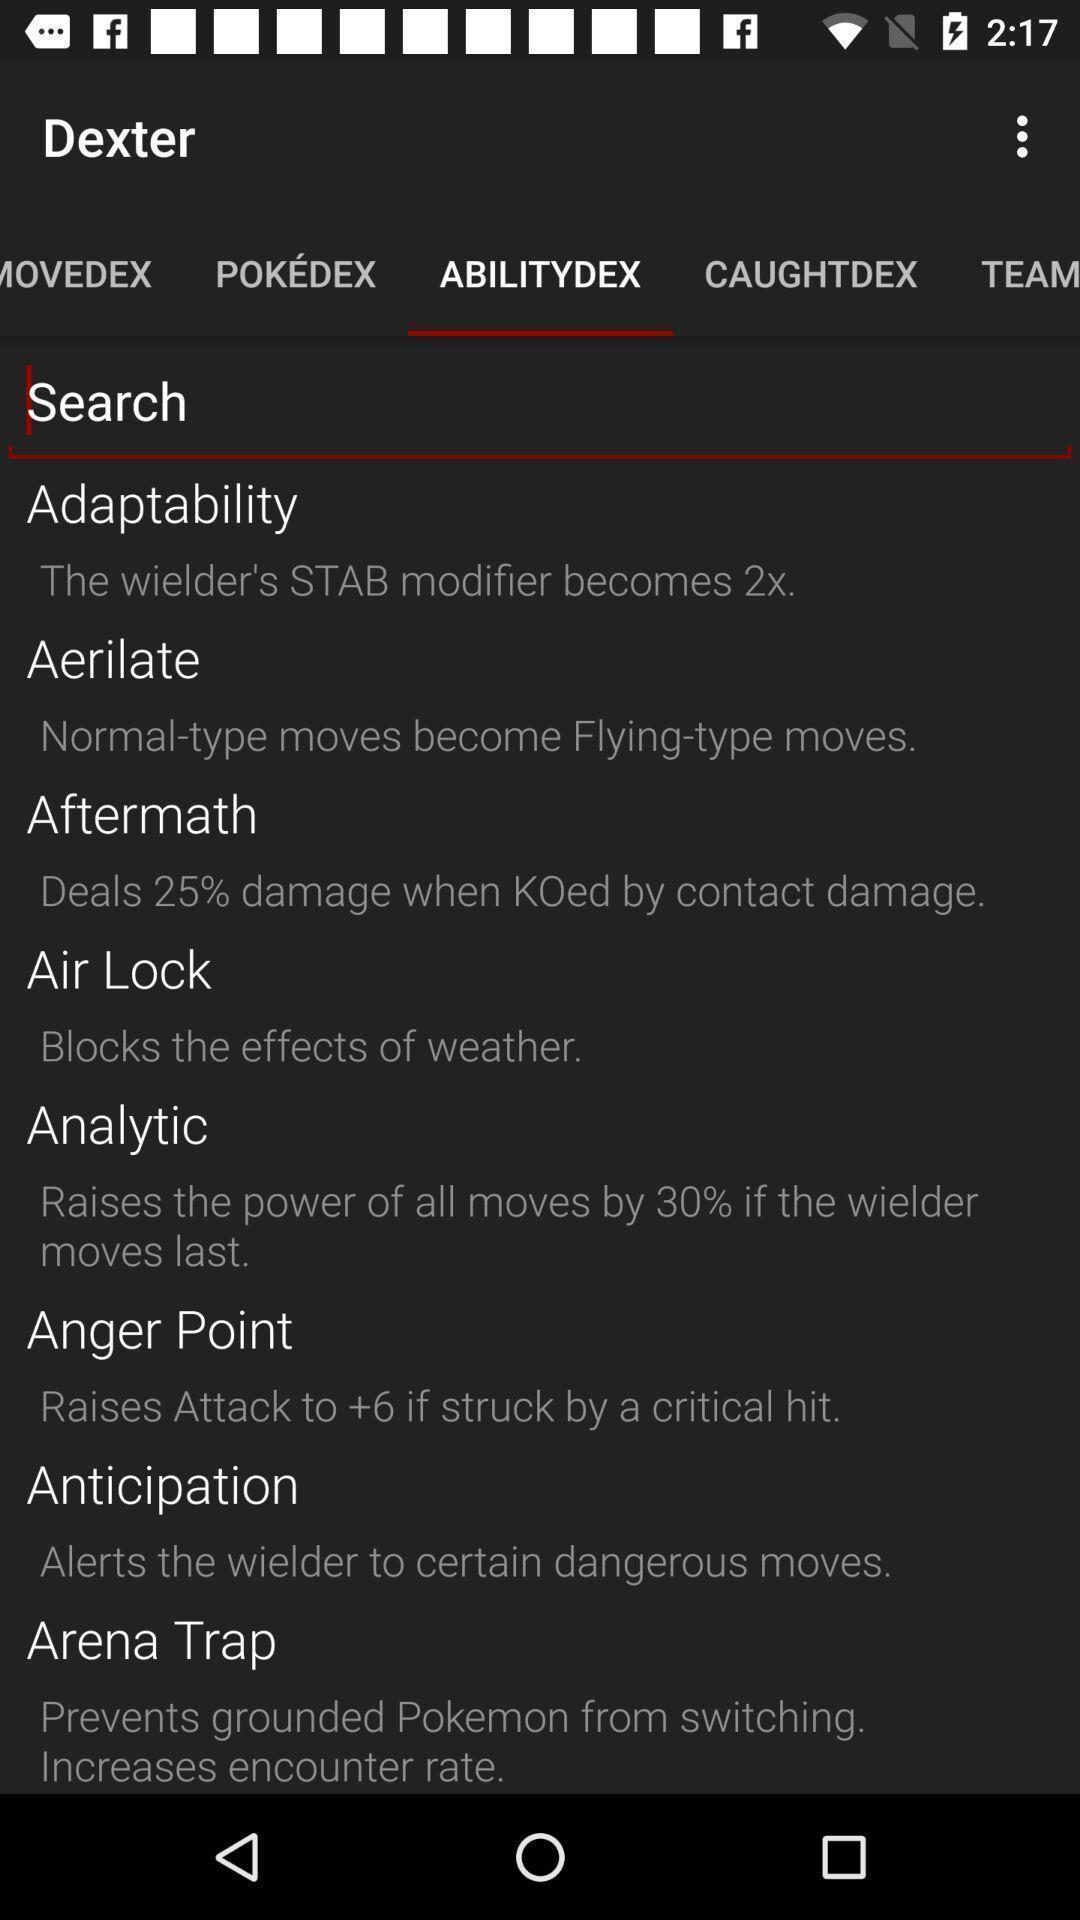Provide a detailed account of this screenshot. Search option to find a different types of settings. 